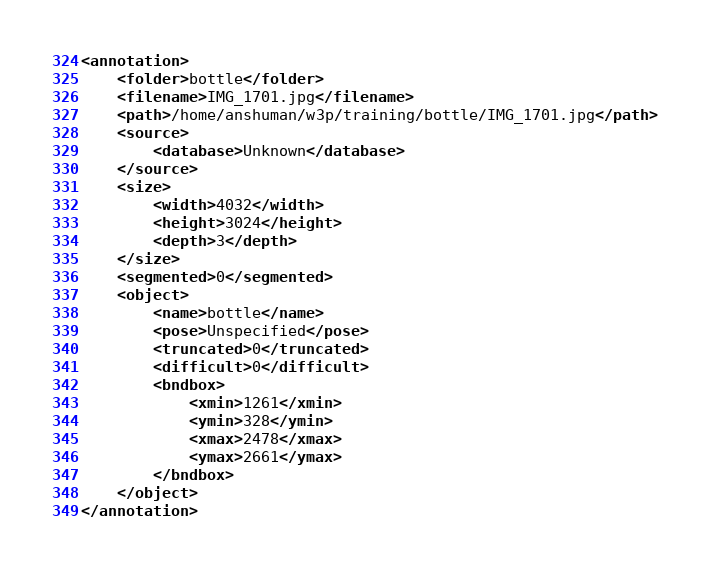<code> <loc_0><loc_0><loc_500><loc_500><_XML_><annotation>
	<folder>bottle</folder>
	<filename>IMG_1701.jpg</filename>
	<path>/home/anshuman/w3p/training/bottle/IMG_1701.jpg</path>
	<source>
		<database>Unknown</database>
	</source>
	<size>
		<width>4032</width>
		<height>3024</height>
		<depth>3</depth>
	</size>
	<segmented>0</segmented>
	<object>
		<name>bottle</name>
		<pose>Unspecified</pose>
		<truncated>0</truncated>
		<difficult>0</difficult>
		<bndbox>
			<xmin>1261</xmin>
			<ymin>328</ymin>
			<xmax>2478</xmax>
			<ymax>2661</ymax>
		</bndbox>
	</object>
</annotation>
</code> 